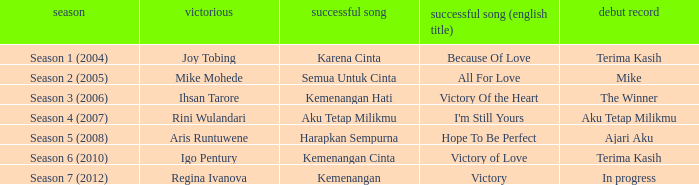Who won with the song kemenangan cinta? Igo Pentury. 